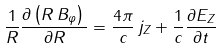<formula> <loc_0><loc_0><loc_500><loc_500>\frac { 1 } { R } \frac { \partial \left ( { R \, B _ { \varphi } } \right ) \, } { \partial R } = \frac { 4 \pi } { c } \, j _ { Z } + \frac { 1 } { c } \frac { \partial E _ { Z } } { \partial t }</formula> 